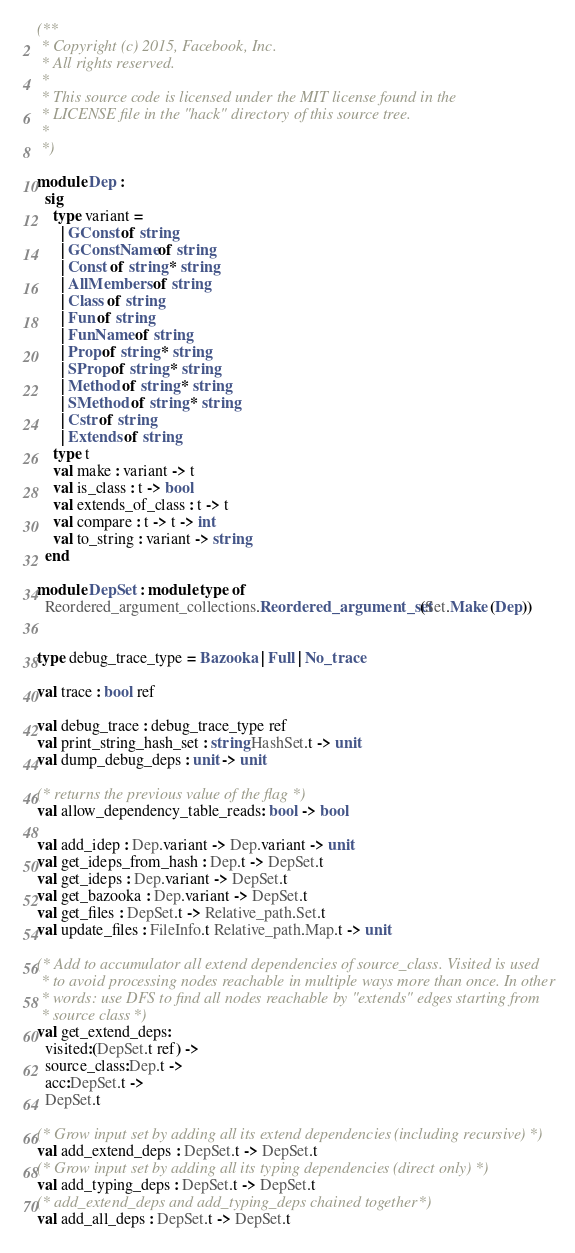Convert code to text. <code><loc_0><loc_0><loc_500><loc_500><_OCaml_>(**
 * Copyright (c) 2015, Facebook, Inc.
 * All rights reserved.
 *
 * This source code is licensed under the MIT license found in the
 * LICENSE file in the "hack" directory of this source tree.
 *
 *)

module Dep :
  sig
    type variant =
      | GConst of string
      | GConstName of string
      | Const of string * string
      | AllMembers of string
      | Class of string
      | Fun of string
      | FunName of string
      | Prop of string * string
      | SProp of string * string
      | Method of string * string
      | SMethod of string * string
      | Cstr of string
      | Extends of string
    type t
    val make : variant -> t
    val is_class : t -> bool
    val extends_of_class : t -> t
    val compare : t -> t -> int
    val to_string : variant -> string
  end

module DepSet : module type of
  Reordered_argument_collections.Reordered_argument_set(Set.Make (Dep))


type debug_trace_type = Bazooka | Full | No_trace

val trace : bool ref

val debug_trace : debug_trace_type ref
val print_string_hash_set : string HashSet.t -> unit
val dump_debug_deps : unit -> unit

(* returns the previous value of the flag *)
val allow_dependency_table_reads: bool -> bool

val add_idep : Dep.variant -> Dep.variant -> unit
val get_ideps_from_hash : Dep.t -> DepSet.t
val get_ideps : Dep.variant -> DepSet.t
val get_bazooka : Dep.variant -> DepSet.t
val get_files : DepSet.t -> Relative_path.Set.t
val update_files : FileInfo.t Relative_path.Map.t -> unit

(* Add to accumulator all extend dependencies of source_class. Visited is used
 * to avoid processing nodes reachable in multiple ways more than once. In other
 * words: use DFS to find all nodes reachable by "extends" edges starting from
 * source class *)
val get_extend_deps:
  visited:(DepSet.t ref) ->
  source_class:Dep.t ->
  acc:DepSet.t ->
  DepSet.t

(* Grow input set by adding all its extend dependencies (including recursive) *)
val add_extend_deps : DepSet.t -> DepSet.t
(* Grow input set by adding all its typing dependencies (direct only) *)
val add_typing_deps : DepSet.t -> DepSet.t
(* add_extend_deps and add_typing_deps chained together *)
val add_all_deps : DepSet.t -> DepSet.t
</code> 